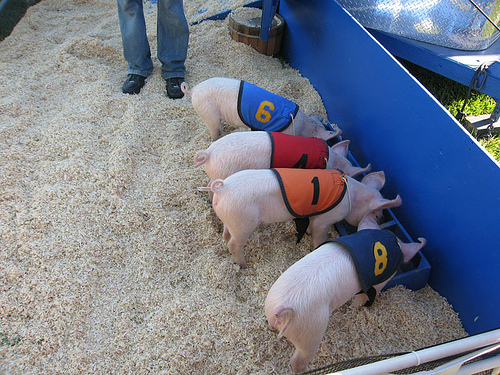<image>
Can you confirm if the number is on the pig? Yes. Looking at the image, I can see the number is positioned on top of the pig, with the pig providing support. 